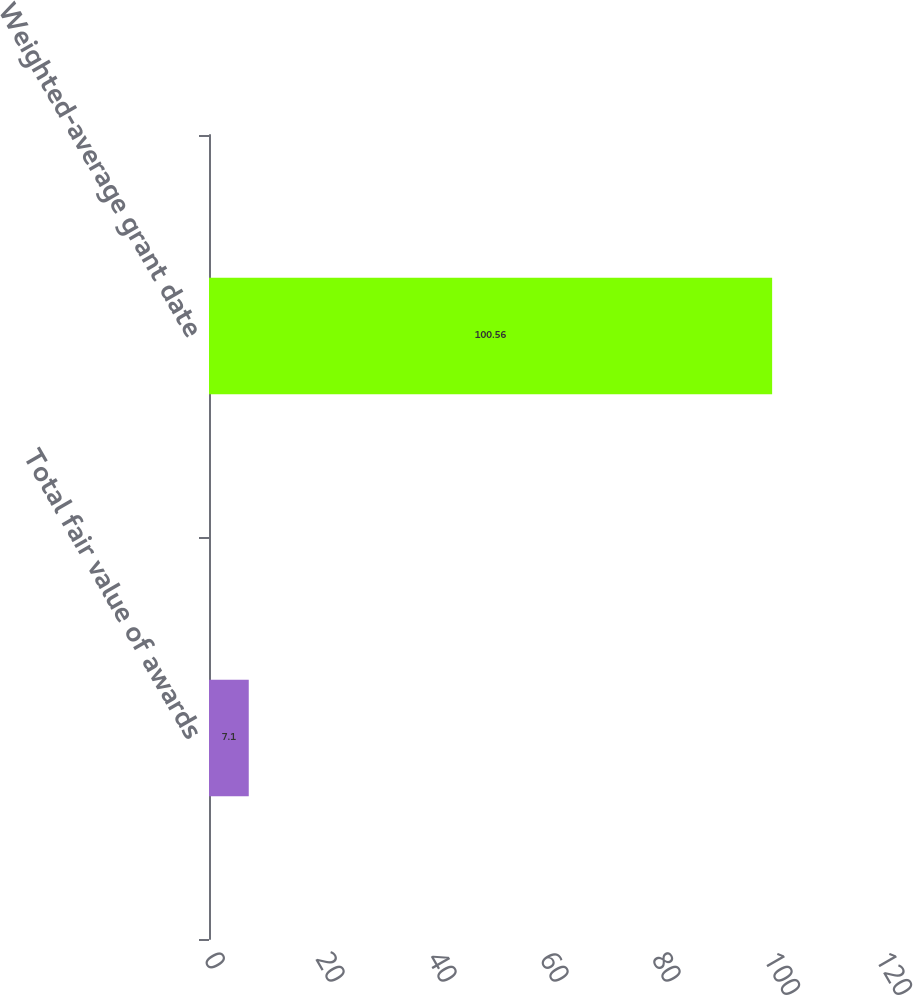Convert chart. <chart><loc_0><loc_0><loc_500><loc_500><bar_chart><fcel>Total fair value of awards<fcel>Weighted-average grant date<nl><fcel>7.1<fcel>100.56<nl></chart> 